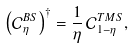Convert formula to latex. <formula><loc_0><loc_0><loc_500><loc_500>\left ( \mathcal { C } _ { \eta } ^ { B S } \right ) ^ { \dagger } = \frac { 1 } { \eta } \, \mathcal { C } _ { 1 - \eta } ^ { T M S } ,</formula> 